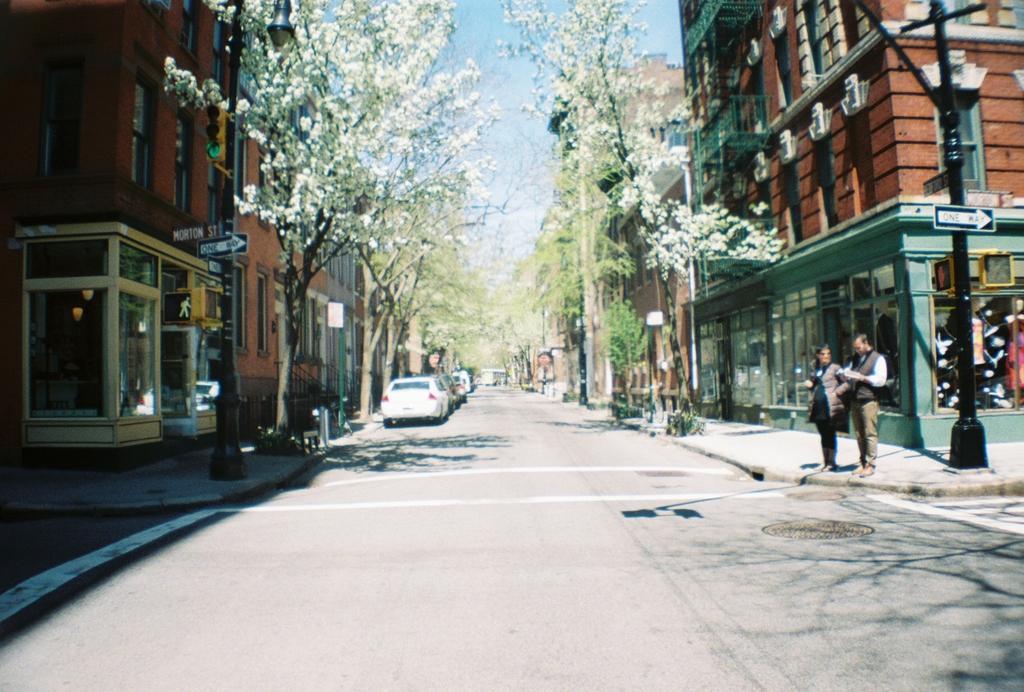Describe this image in one or two sentences. In this image, we can see a road, at the left side there are some cars parked, at the right side there are two persons standing on the path, there is a black color pole, we can see some buildings, at the top there is a blue color sky. 